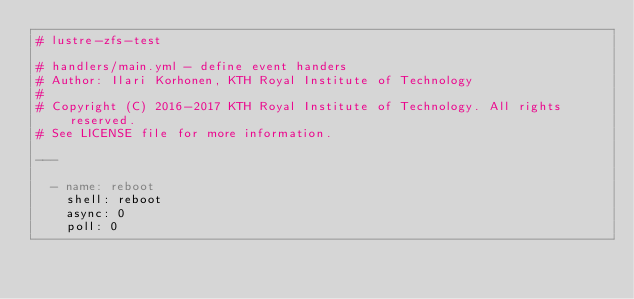Convert code to text. <code><loc_0><loc_0><loc_500><loc_500><_YAML_># lustre-zfs-test

# handlers/main.yml - define event handers
# Author: Ilari Korhonen, KTH Royal Institute of Technology
#
# Copyright (C) 2016-2017 KTH Royal Institute of Technology. All rights reserved.
# See LICENSE file for more information.

---

  - name: reboot
    shell: reboot
    async: 0
    poll: 0
</code> 